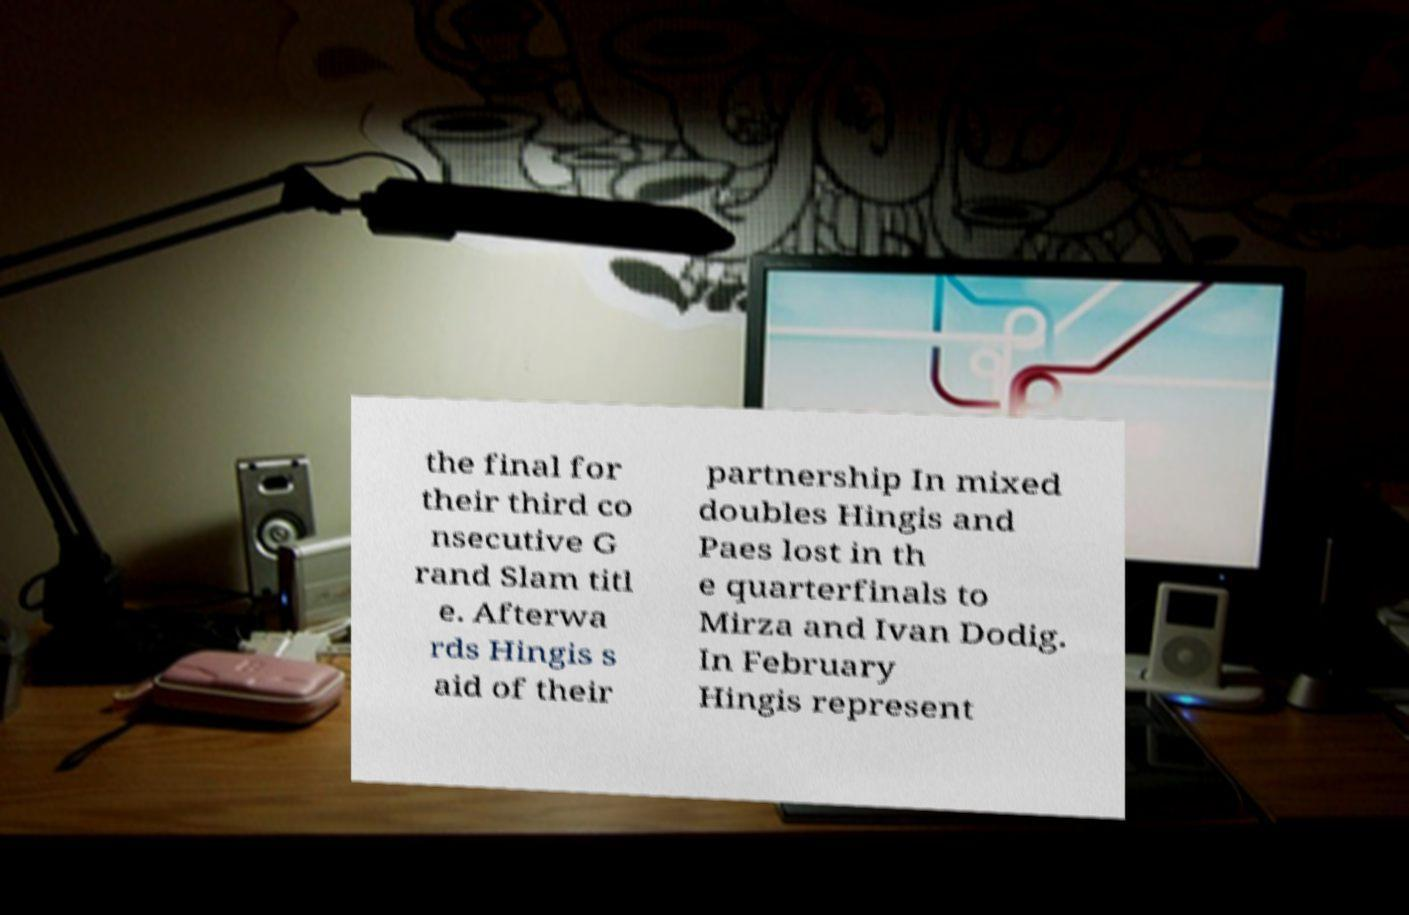For documentation purposes, I need the text within this image transcribed. Could you provide that? the final for their third co nsecutive G rand Slam titl e. Afterwa rds Hingis s aid of their partnership In mixed doubles Hingis and Paes lost in th e quarterfinals to Mirza and Ivan Dodig. In February Hingis represent 